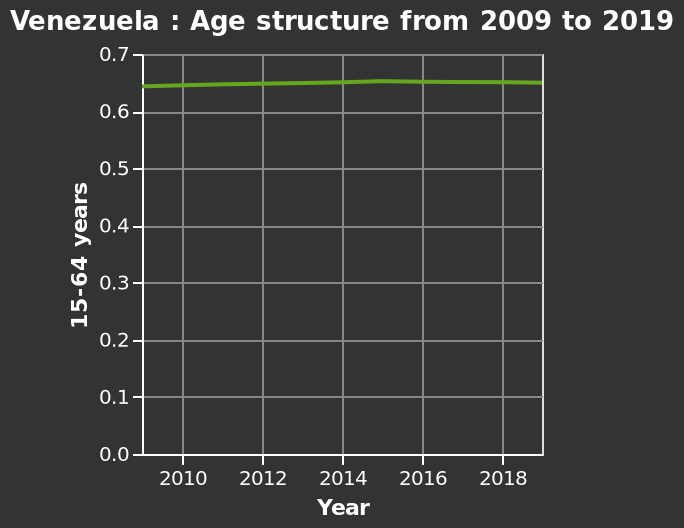<image>
What is the scale of the y-axis? The y-axis is measured on a scale from 0.0 to 0.7. What age group is represented on the y-axis? The y-axis represents the age group of 15-64 years. 